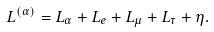<formula> <loc_0><loc_0><loc_500><loc_500>L ^ { ( \alpha ) } = L _ { \alpha } + L _ { e } + L _ { \mu } + L _ { \tau } + \eta .</formula> 